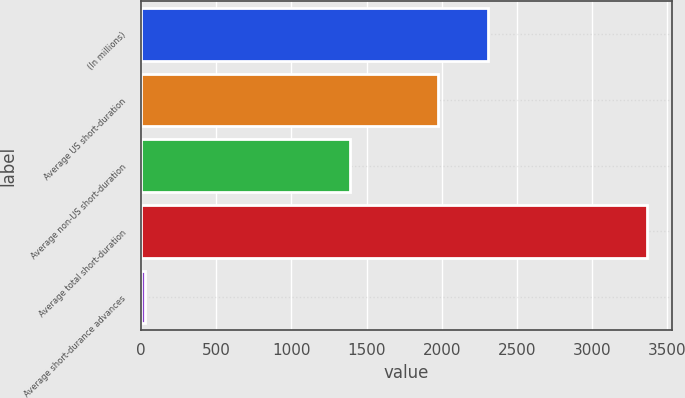Convert chart. <chart><loc_0><loc_0><loc_500><loc_500><bar_chart><fcel>(In millions)<fcel>Average US short-duration<fcel>Average non-US short-duration<fcel>Average total short-duration<fcel>Average short-durance advances<nl><fcel>2305.6<fcel>1972<fcel>1393<fcel>3365<fcel>29<nl></chart> 